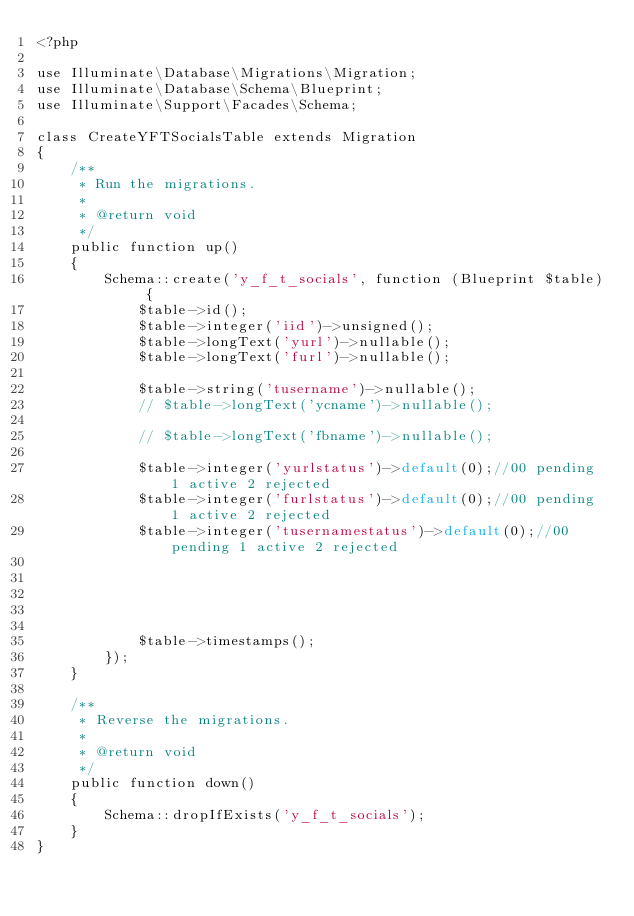Convert code to text. <code><loc_0><loc_0><loc_500><loc_500><_PHP_><?php

use Illuminate\Database\Migrations\Migration;
use Illuminate\Database\Schema\Blueprint;
use Illuminate\Support\Facades\Schema;

class CreateYFTSocialsTable extends Migration
{
    /**
     * Run the migrations.
     *
     * @return void
     */
    public function up()
    {
        Schema::create('y_f_t_socials', function (Blueprint $table) {
            $table->id();
            $table->integer('iid')->unsigned();
            $table->longText('yurl')->nullable();
            $table->longText('furl')->nullable();
  
            $table->string('tusername')->nullable();
            // $table->longText('ycname')->nullable();
       
            // $table->longText('fbname')->nullable();
          
            $table->integer('yurlstatus')->default(0);//00 pending 1 active 2 rejected
            $table->integer('furlstatus')->default(0);//00 pending 1 active 2 rejected
            $table->integer('tusernamestatus')->default(0);//00 pending 1 active 2 rejected

            
        

            
            $table->timestamps();
        });
    }

    /**
     * Reverse the migrations.
     *
     * @return void
     */
    public function down()
    {
        Schema::dropIfExists('y_f_t_socials');
    }
}
</code> 